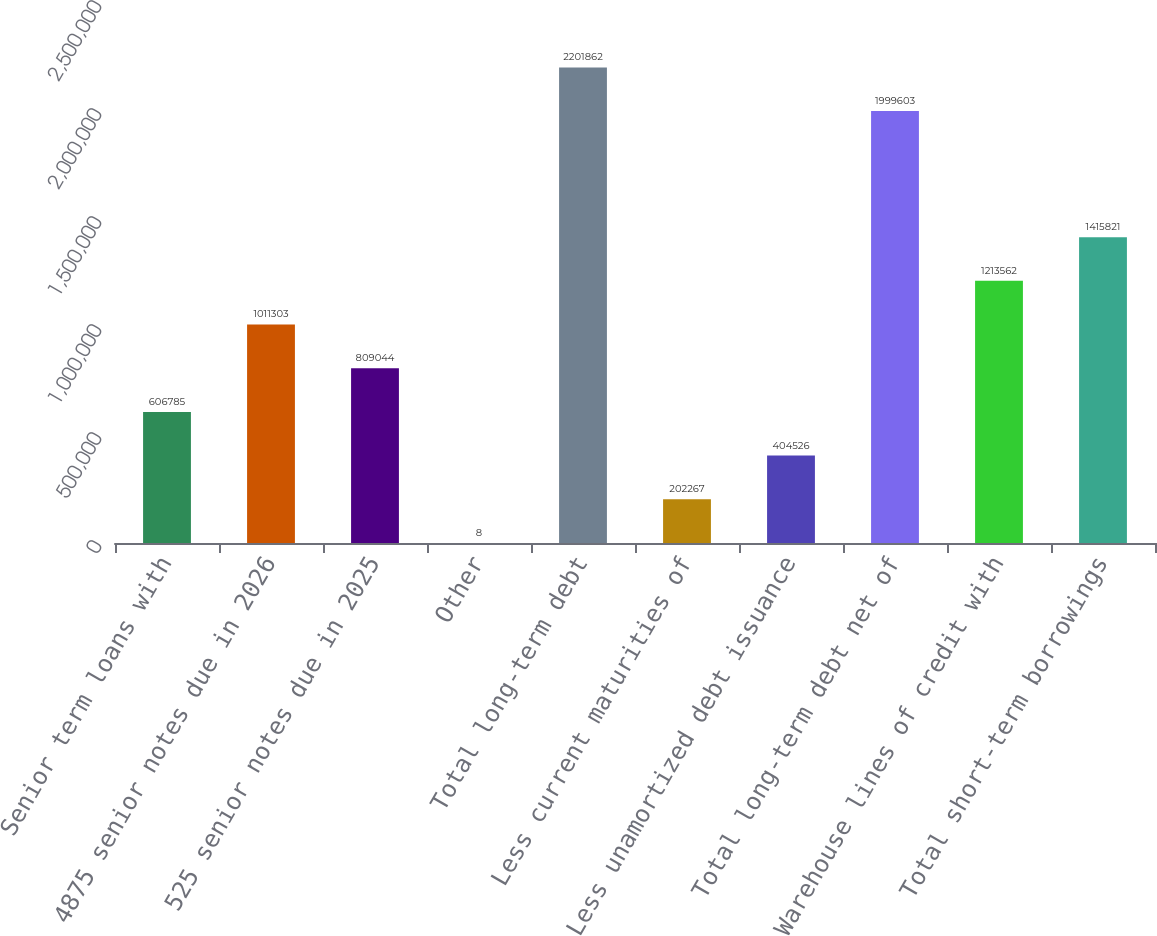Convert chart to OTSL. <chart><loc_0><loc_0><loc_500><loc_500><bar_chart><fcel>Senior term loans with<fcel>4875 senior notes due in 2026<fcel>525 senior notes due in 2025<fcel>Other<fcel>Total long-term debt<fcel>Less current maturities of<fcel>Less unamortized debt issuance<fcel>Total long-term debt net of<fcel>Warehouse lines of credit with<fcel>Total short-term borrowings<nl><fcel>606785<fcel>1.0113e+06<fcel>809044<fcel>8<fcel>2.20186e+06<fcel>202267<fcel>404526<fcel>1.9996e+06<fcel>1.21356e+06<fcel>1.41582e+06<nl></chart> 